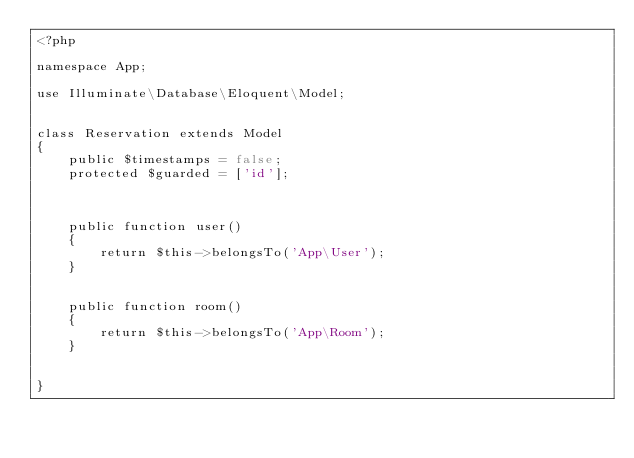Convert code to text. <code><loc_0><loc_0><loc_500><loc_500><_PHP_><?php

namespace App;

use Illuminate\Database\Eloquent\Model;


class Reservation extends Model
{
    public $timestamps = false;
    protected $guarded = ['id'];



    public function user()
    {
        return $this->belongsTo('App\User');
    }


    public function room()
    {
        return $this->belongsTo('App\Room');
    }


}
</code> 